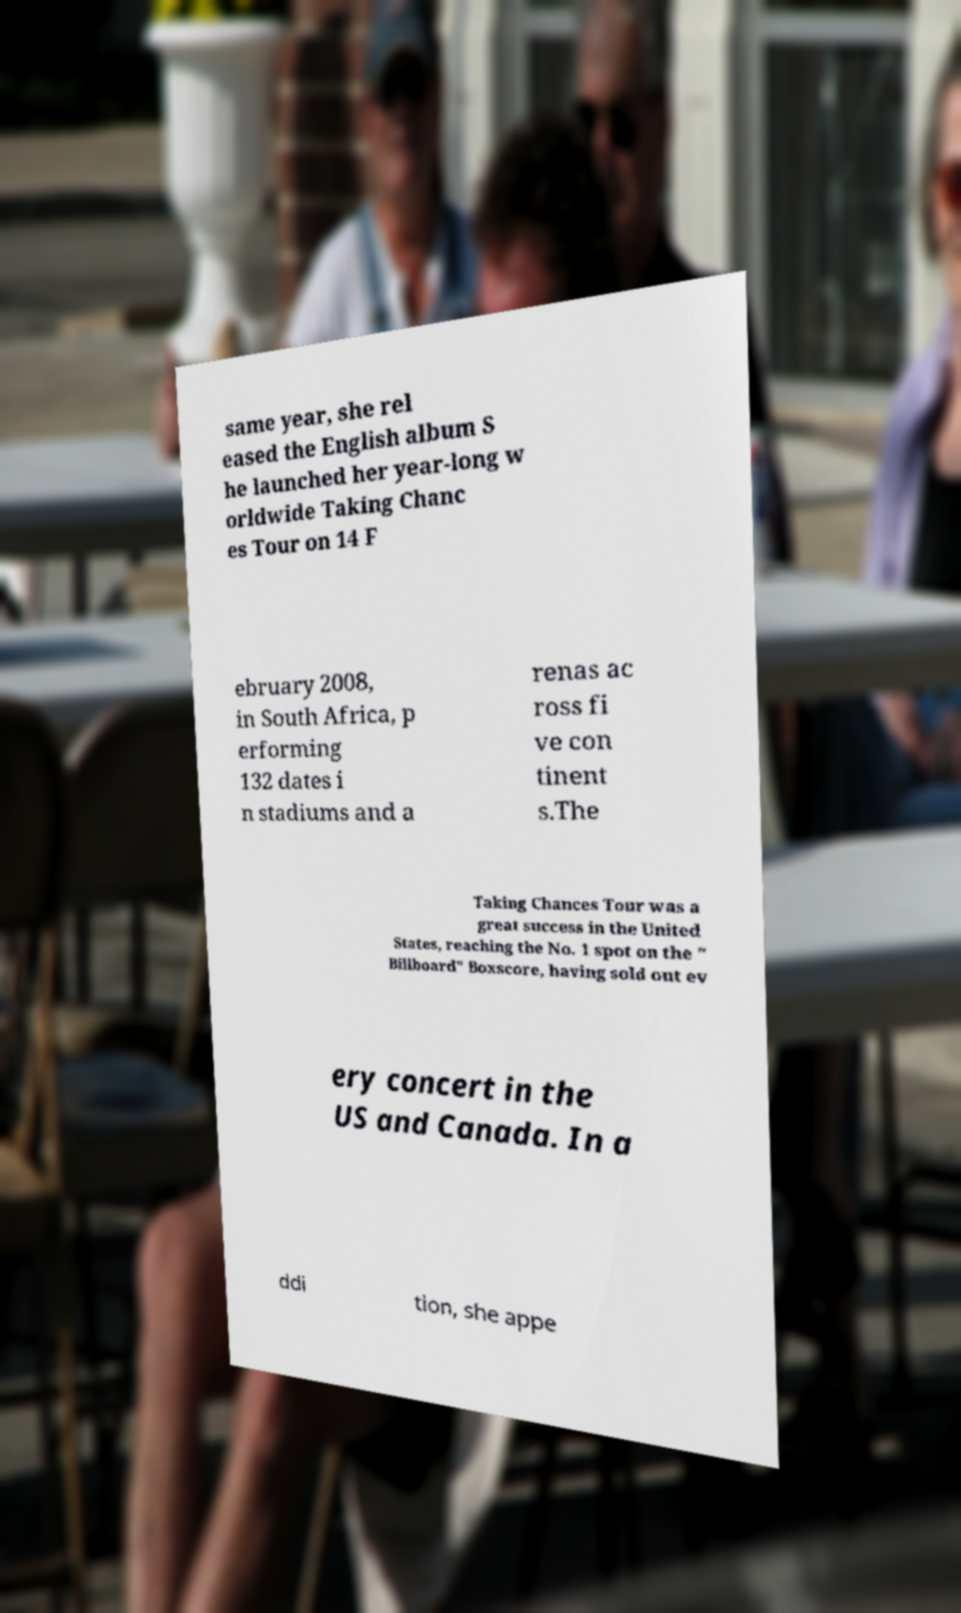For documentation purposes, I need the text within this image transcribed. Could you provide that? same year, she rel eased the English album S he launched her year-long w orldwide Taking Chanc es Tour on 14 F ebruary 2008, in South Africa, p erforming 132 dates i n stadiums and a renas ac ross fi ve con tinent s.The Taking Chances Tour was a great success in the United States, reaching the No. 1 spot on the " Billboard" Boxscore, having sold out ev ery concert in the US and Canada. In a ddi tion, she appe 